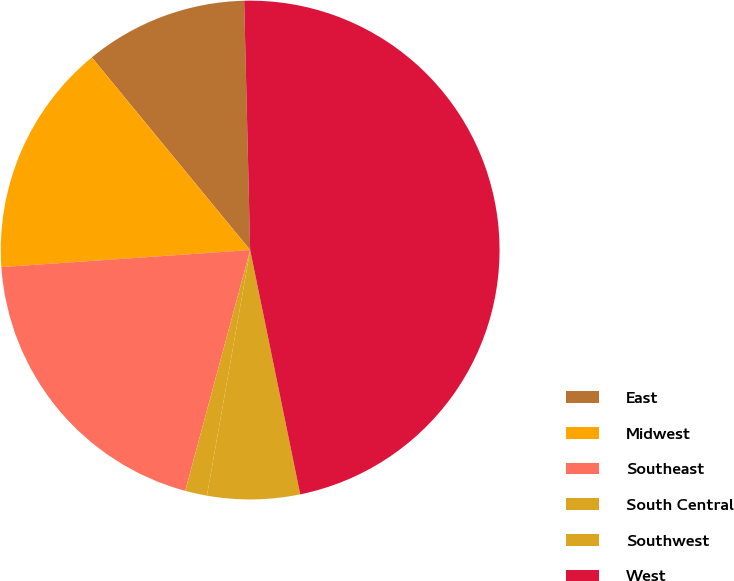<chart> <loc_0><loc_0><loc_500><loc_500><pie_chart><fcel>East<fcel>Midwest<fcel>Southeast<fcel>South Central<fcel>Southwest<fcel>West<nl><fcel>10.57%<fcel>15.14%<fcel>19.72%<fcel>1.42%<fcel>5.99%<fcel>47.17%<nl></chart> 